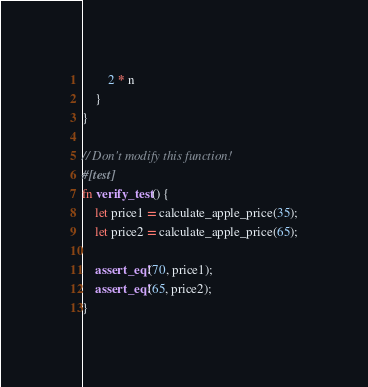Convert code to text. <code><loc_0><loc_0><loc_500><loc_500><_Rust_>        2 * n
    }
}

// Don't modify this function!
#[test]
fn verify_test() {
    let price1 = calculate_apple_price(35);
    let price2 = calculate_apple_price(65);

    assert_eq!(70, price1);
    assert_eq!(65, price2);
}
</code> 